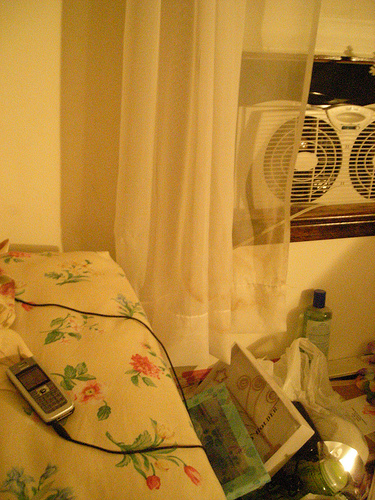<image>
Is the mobile on the pillow? Yes. Looking at the image, I can see the mobile is positioned on top of the pillow, with the pillow providing support. 